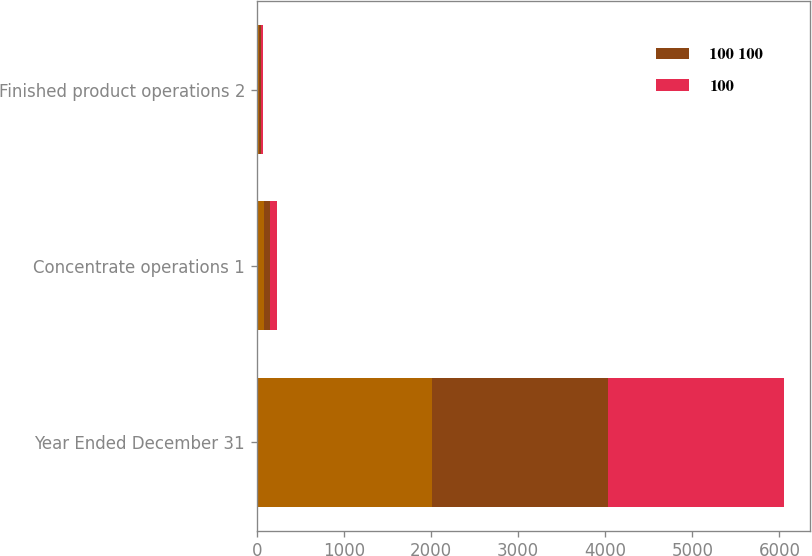<chart> <loc_0><loc_0><loc_500><loc_500><stacked_bar_chart><ecel><fcel>Year Ended December 31<fcel>Concentrate operations 1<fcel>Finished product operations 2<nl><fcel>nan<fcel>2017<fcel>78<fcel>22<nl><fcel>100 100<fcel>2016<fcel>76<fcel>24<nl><fcel>100<fcel>2015<fcel>73<fcel>27<nl></chart> 